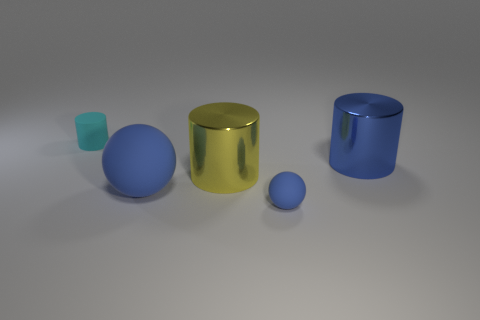What number of other yellow objects have the same size as the yellow metallic thing?
Ensure brevity in your answer.  0. What number of objects are both behind the large matte object and on the right side of the large yellow cylinder?
Provide a short and direct response. 1. Does the blue matte sphere on the left side of the yellow metal cylinder have the same size as the big yellow object?
Your answer should be compact. Yes. Are there any big metal cylinders of the same color as the big rubber thing?
Offer a terse response. Yes. There is a cyan object that is the same material as the big sphere; what is its size?
Provide a short and direct response. Small. Is the number of tiny matte things left of the tiny matte cylinder greater than the number of small cyan objects in front of the large yellow metal thing?
Provide a short and direct response. No. What number of other objects are there of the same material as the cyan thing?
Keep it short and to the point. 2. Is the material of the tiny thing that is left of the tiny blue ball the same as the tiny sphere?
Give a very brief answer. Yes. The small blue matte object is what shape?
Your answer should be compact. Sphere. Is the number of large shiny cylinders behind the large yellow shiny object greater than the number of big brown rubber balls?
Give a very brief answer. Yes. 